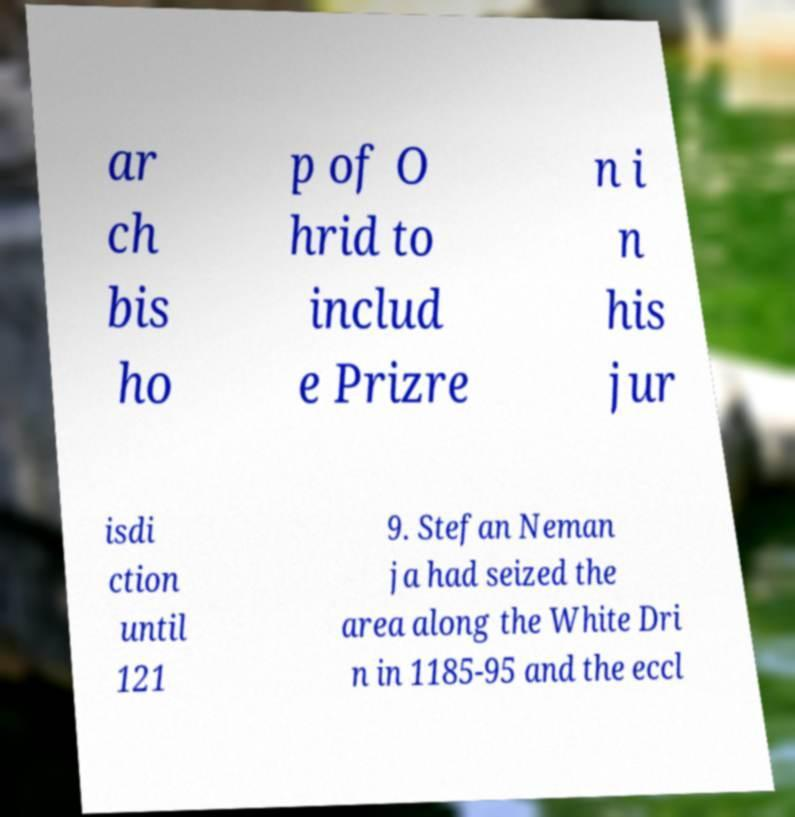What messages or text are displayed in this image? I need them in a readable, typed format. ar ch bis ho p of O hrid to includ e Prizre n i n his jur isdi ction until 121 9. Stefan Neman ja had seized the area along the White Dri n in 1185-95 and the eccl 